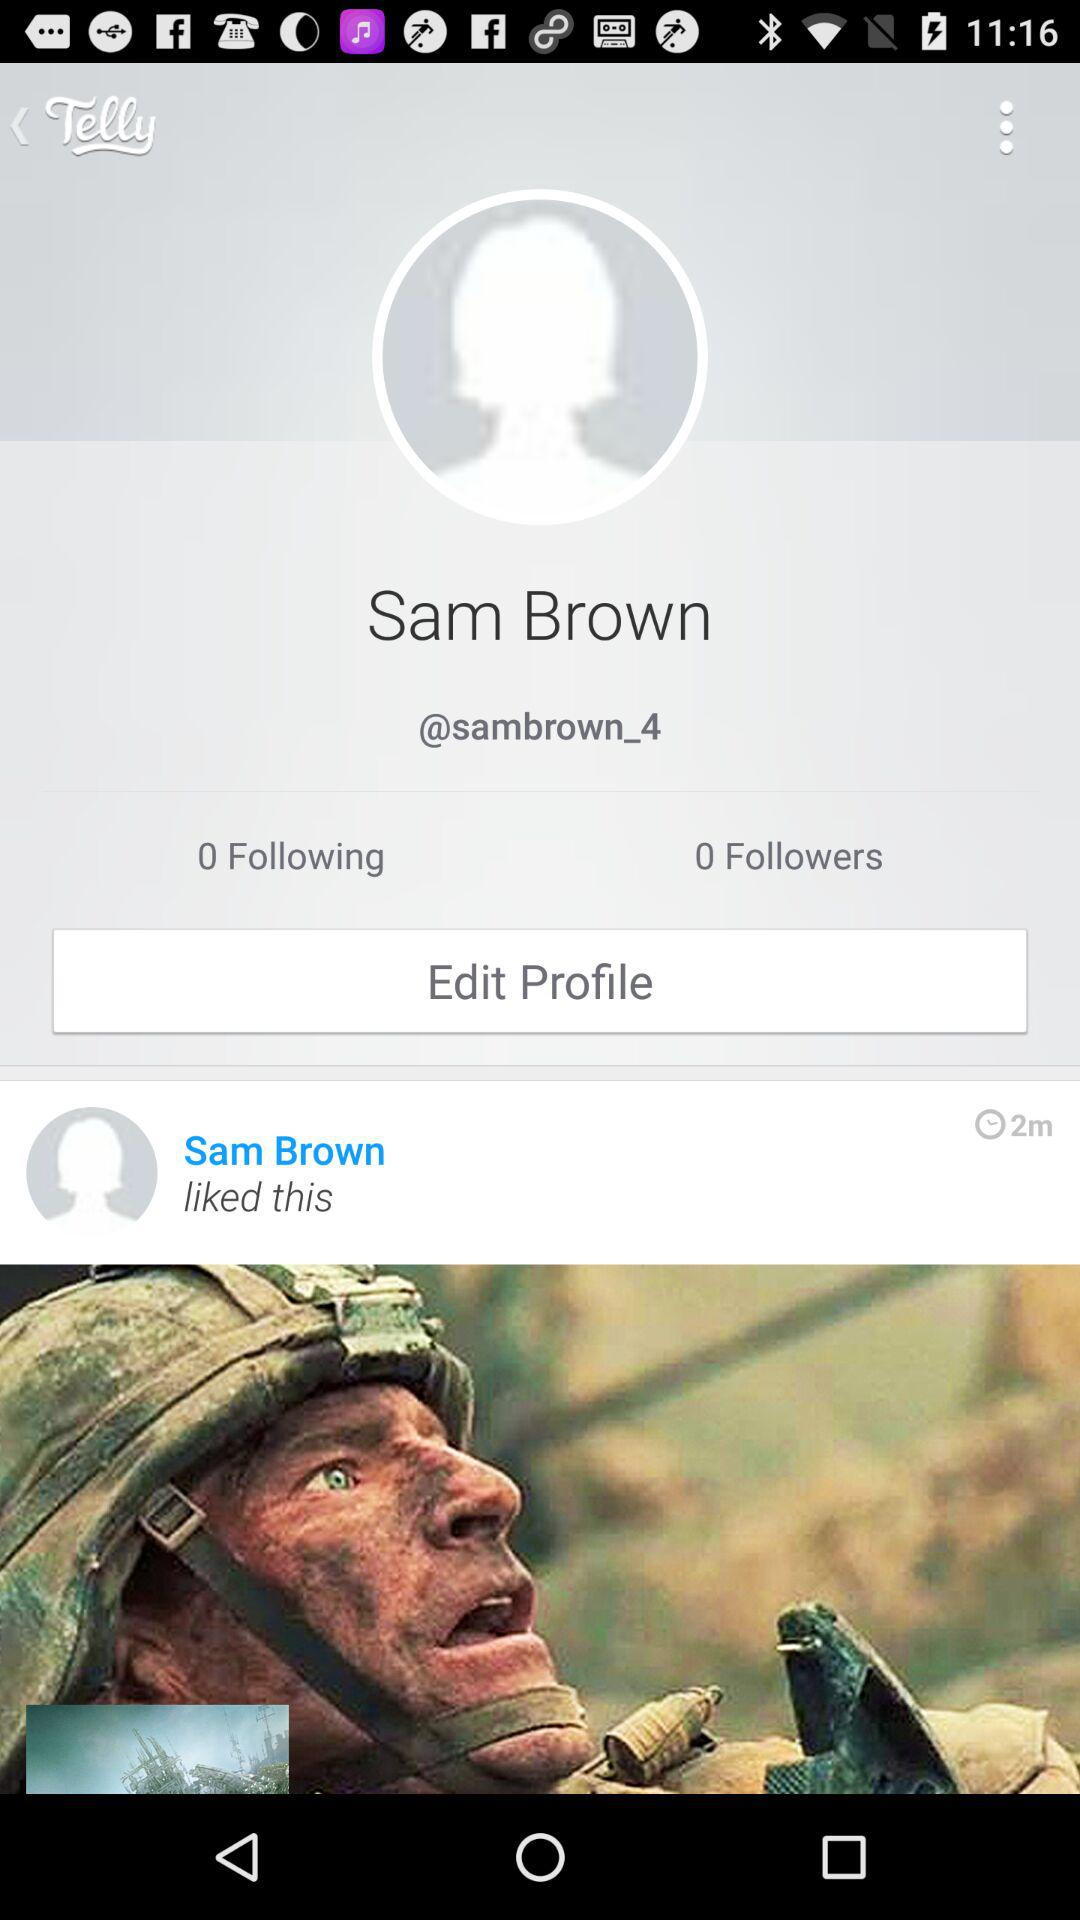Whose profile is opened? The person whose profile is opened is Sam Brown. 